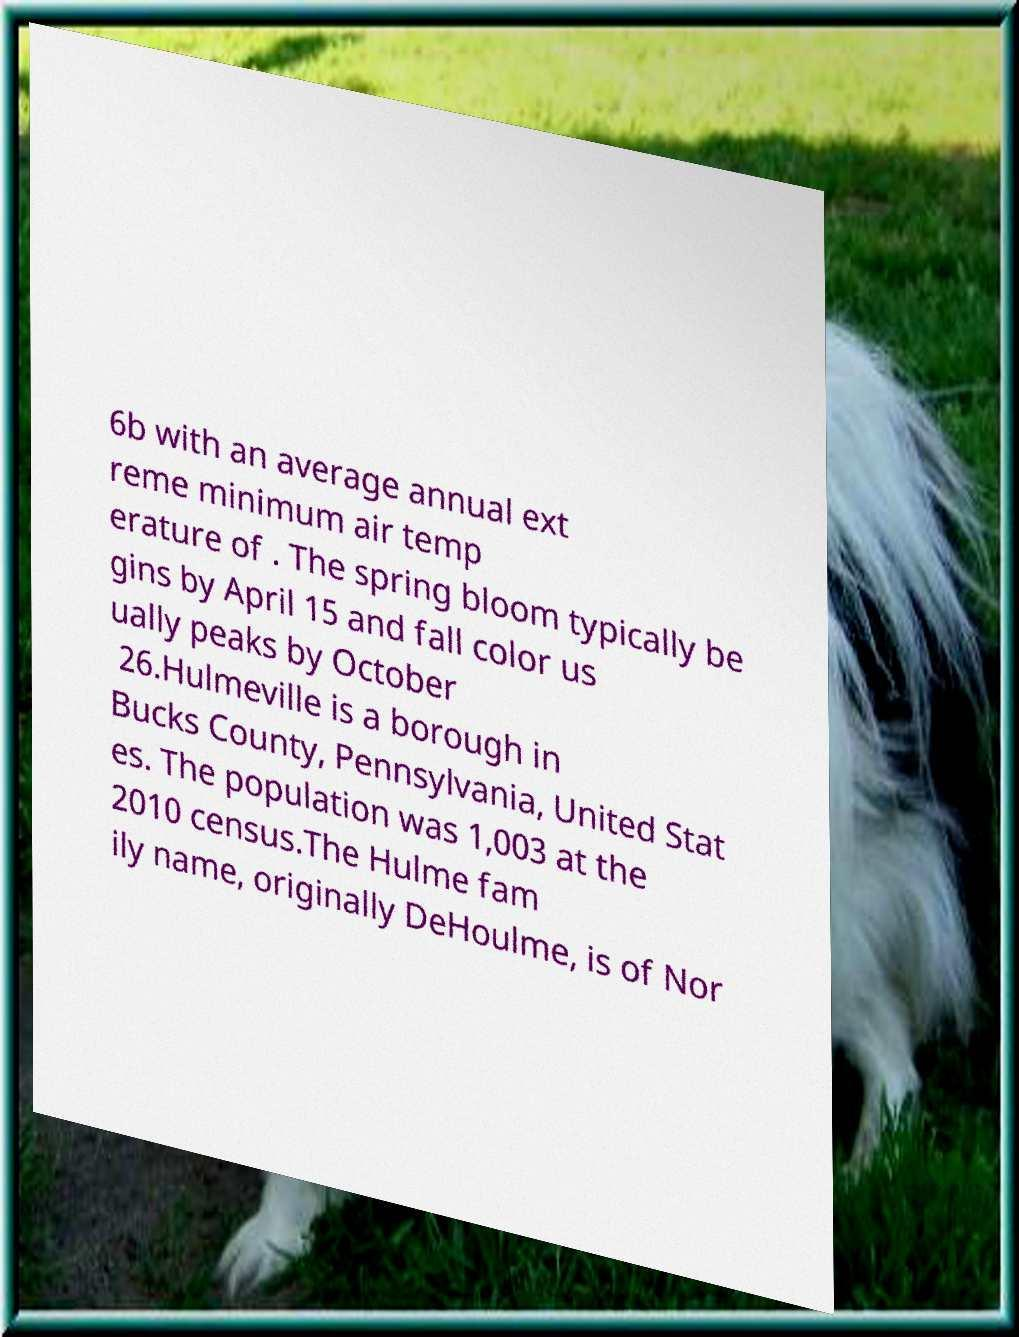Can you read and provide the text displayed in the image?This photo seems to have some interesting text. Can you extract and type it out for me? 6b with an average annual ext reme minimum air temp erature of . The spring bloom typically be gins by April 15 and fall color us ually peaks by October 26.Hulmeville is a borough in Bucks County, Pennsylvania, United Stat es. The population was 1,003 at the 2010 census.The Hulme fam ily name, originally DeHoulme, is of Nor 